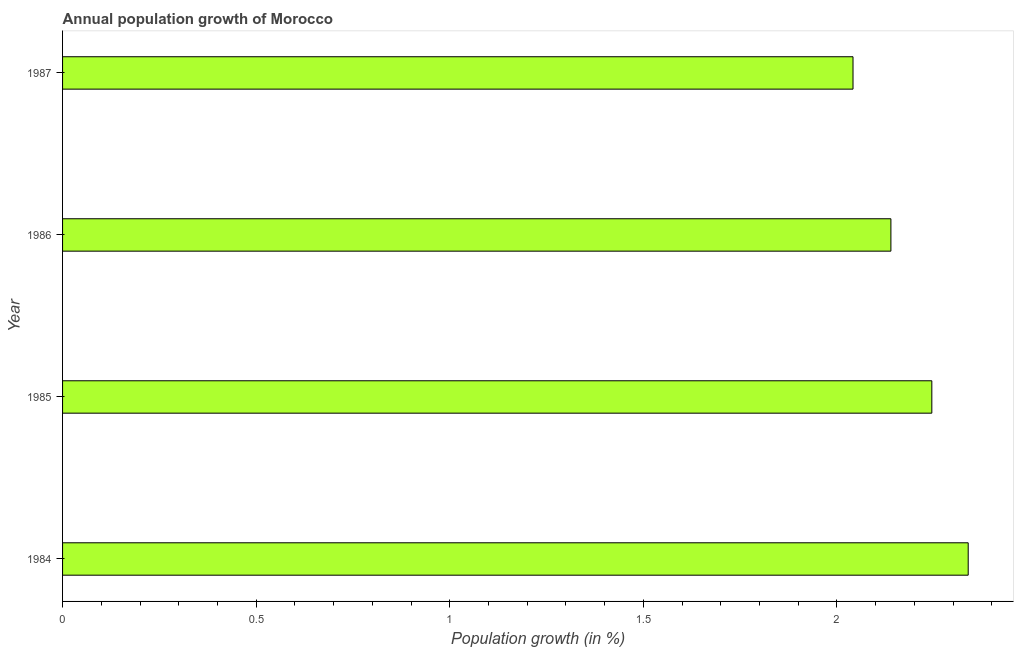Does the graph contain any zero values?
Your answer should be very brief. No. Does the graph contain grids?
Offer a terse response. No. What is the title of the graph?
Keep it short and to the point. Annual population growth of Morocco. What is the label or title of the X-axis?
Provide a short and direct response. Population growth (in %). What is the label or title of the Y-axis?
Give a very brief answer. Year. What is the population growth in 1986?
Offer a very short reply. 2.14. Across all years, what is the maximum population growth?
Provide a succinct answer. 2.34. Across all years, what is the minimum population growth?
Provide a succinct answer. 2.04. In which year was the population growth maximum?
Give a very brief answer. 1984. What is the sum of the population growth?
Your answer should be very brief. 8.76. What is the difference between the population growth in 1984 and 1986?
Provide a short and direct response. 0.2. What is the average population growth per year?
Offer a terse response. 2.19. What is the median population growth?
Ensure brevity in your answer.  2.19. What is the ratio of the population growth in 1985 to that in 1986?
Give a very brief answer. 1.05. Is the population growth in 1985 less than that in 1986?
Offer a terse response. No. Is the difference between the population growth in 1984 and 1986 greater than the difference between any two years?
Make the answer very short. No. What is the difference between the highest and the second highest population growth?
Your answer should be very brief. 0.09. What is the difference between the highest and the lowest population growth?
Your answer should be compact. 0.3. Are all the bars in the graph horizontal?
Provide a short and direct response. Yes. How many years are there in the graph?
Make the answer very short. 4. What is the difference between two consecutive major ticks on the X-axis?
Make the answer very short. 0.5. Are the values on the major ticks of X-axis written in scientific E-notation?
Provide a short and direct response. No. What is the Population growth (in %) in 1984?
Make the answer very short. 2.34. What is the Population growth (in %) in 1985?
Ensure brevity in your answer.  2.24. What is the Population growth (in %) of 1986?
Offer a terse response. 2.14. What is the Population growth (in %) of 1987?
Your answer should be compact. 2.04. What is the difference between the Population growth (in %) in 1984 and 1985?
Your answer should be compact. 0.09. What is the difference between the Population growth (in %) in 1984 and 1986?
Your answer should be compact. 0.2. What is the difference between the Population growth (in %) in 1984 and 1987?
Provide a succinct answer. 0.3. What is the difference between the Population growth (in %) in 1985 and 1986?
Keep it short and to the point. 0.11. What is the difference between the Population growth (in %) in 1985 and 1987?
Keep it short and to the point. 0.2. What is the difference between the Population growth (in %) in 1986 and 1987?
Provide a succinct answer. 0.1. What is the ratio of the Population growth (in %) in 1984 to that in 1985?
Your response must be concise. 1.04. What is the ratio of the Population growth (in %) in 1984 to that in 1986?
Ensure brevity in your answer.  1.09. What is the ratio of the Population growth (in %) in 1984 to that in 1987?
Offer a terse response. 1.15. What is the ratio of the Population growth (in %) in 1985 to that in 1986?
Provide a short and direct response. 1.05. What is the ratio of the Population growth (in %) in 1985 to that in 1987?
Keep it short and to the point. 1.1. What is the ratio of the Population growth (in %) in 1986 to that in 1987?
Your response must be concise. 1.05. 